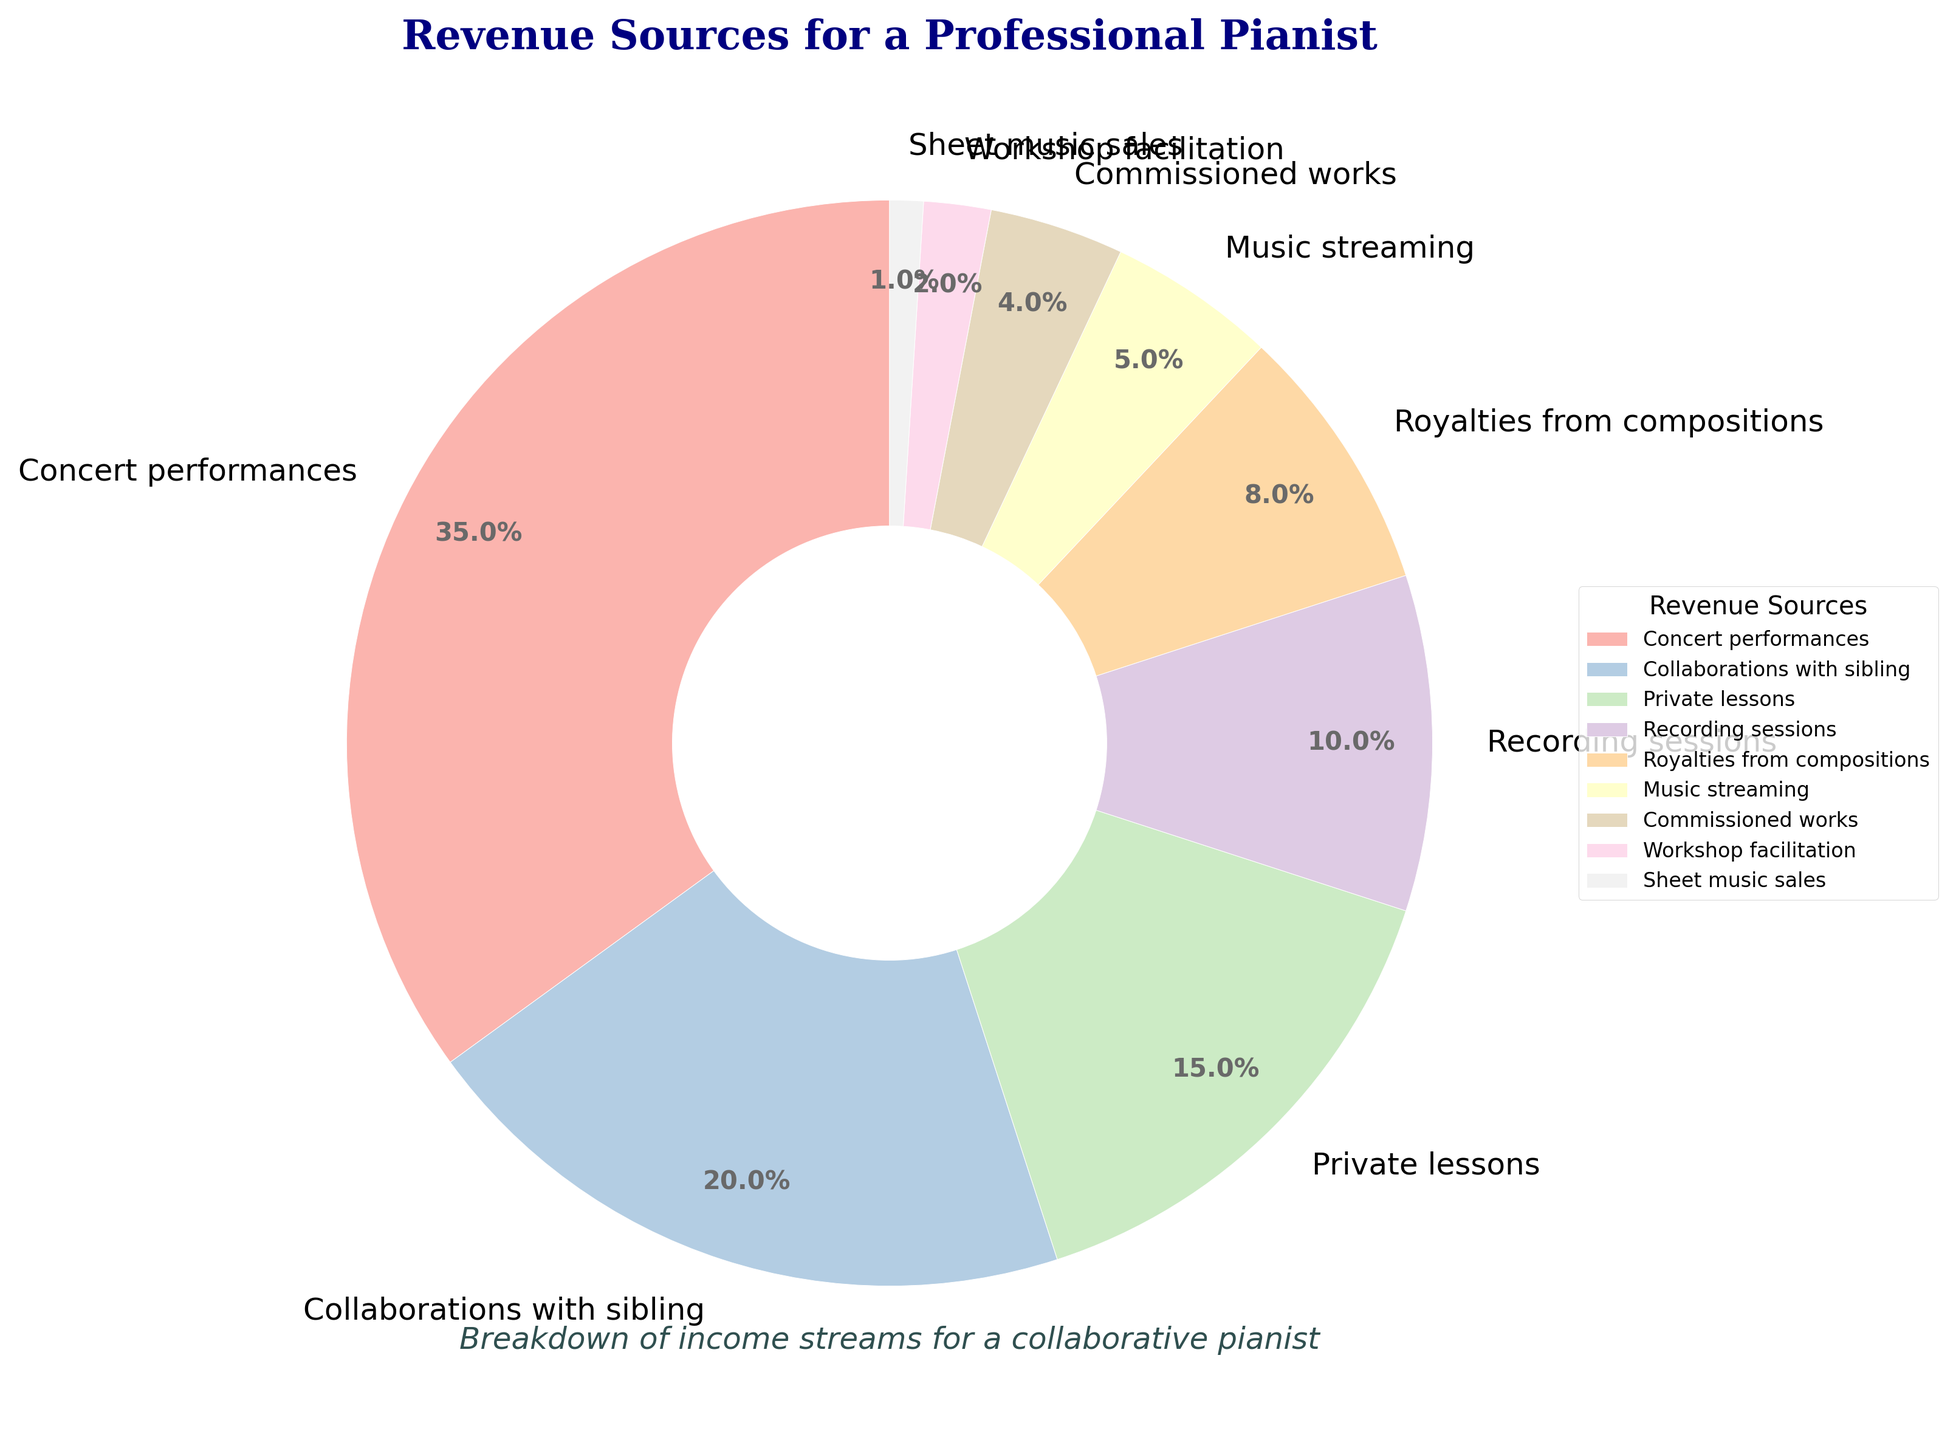Which revenue source accounts for the largest percentage? The pie chart shows that "Concert performances" has the largest slice, indicating the highest percentage.
Answer: Concert performances What percentage of revenue comes from music streaming and sheet music sales combined? Add the percentages of "Music streaming" (5%) and "Sheet music sales" (1%).
Answer: 6% How much more revenue do concert performances generate compared to private lessons? Subtract the percentage of "Private lessons" (15%) from that of "Concert performances" (35%).
Answer: 20% Rank the revenue sources from highest to lowest percentage. From the largest to the smallest slice: Concert performances (35%), Collaborations with sibling (20%), Private lessons (15%), Recording sessions (10%), Royalties from compositions (8%), Music streaming (5%), Commissioned works (4%), Workshop facilitation (2%), Sheet music sales (1%).
Answer: Concert performances > Collaborations with sibling > Private lessons > Recording sessions > Royalties from compositions > Music streaming > Commissioned works > Workshop facilitation > Sheet music sales Which revenue sources together account for 25% of the revenue? The sums of "Music streaming" (5%) + "Commissioned works" (4%) + "Workshop facilitation" (2%) = 11%, and "Private lessons" (15%) account for 26% alone, overshooting the target. However, "Recording sessions" (10%) + "Royalties from compositions" (8%) + "Music streaming" (5%) + "Sheet music sales" (1%) = 24%, slightly less. Therefore, finding exact combinations that perfectly sum to 25% is inconsistent here.
Answer: Approx. Recording sessions + Royalties from compositions + Music streaming + Sheet music sales = 24% Is the revenue from collaborations with your sibling greater than the revenue from recording sessions and royalties from compositions combined? Combine the percentages of "Recording sessions" (10%) and "Royalties from compositions" (8%), summing up to 18%, which is less than "Collaborations with sibling" (20%).
Answer: Yes How do the percentages of royalties from compositions and private lessons compare? The percentage for "Private lessons" (15%) is higher than for "Royalties from compositions" (8%).
Answer: Private lessons are higher What percentage of revenue does recording sessions contribute compared to concert performances? Calculate the ratio of "Recording sessions" (10%) to "Concert performances" (35%).
Answer: ~29% If you combine the percentages of private lessons, recording sessions, and royalties from compositions, how does this compare to concert performances? Add "Private lessons" (15%), "Recording sessions" (10%), and "Royalties from compositions" (8%) to get 33%, which is slightly less than "Concert performances" (35%).
Answer: Less 